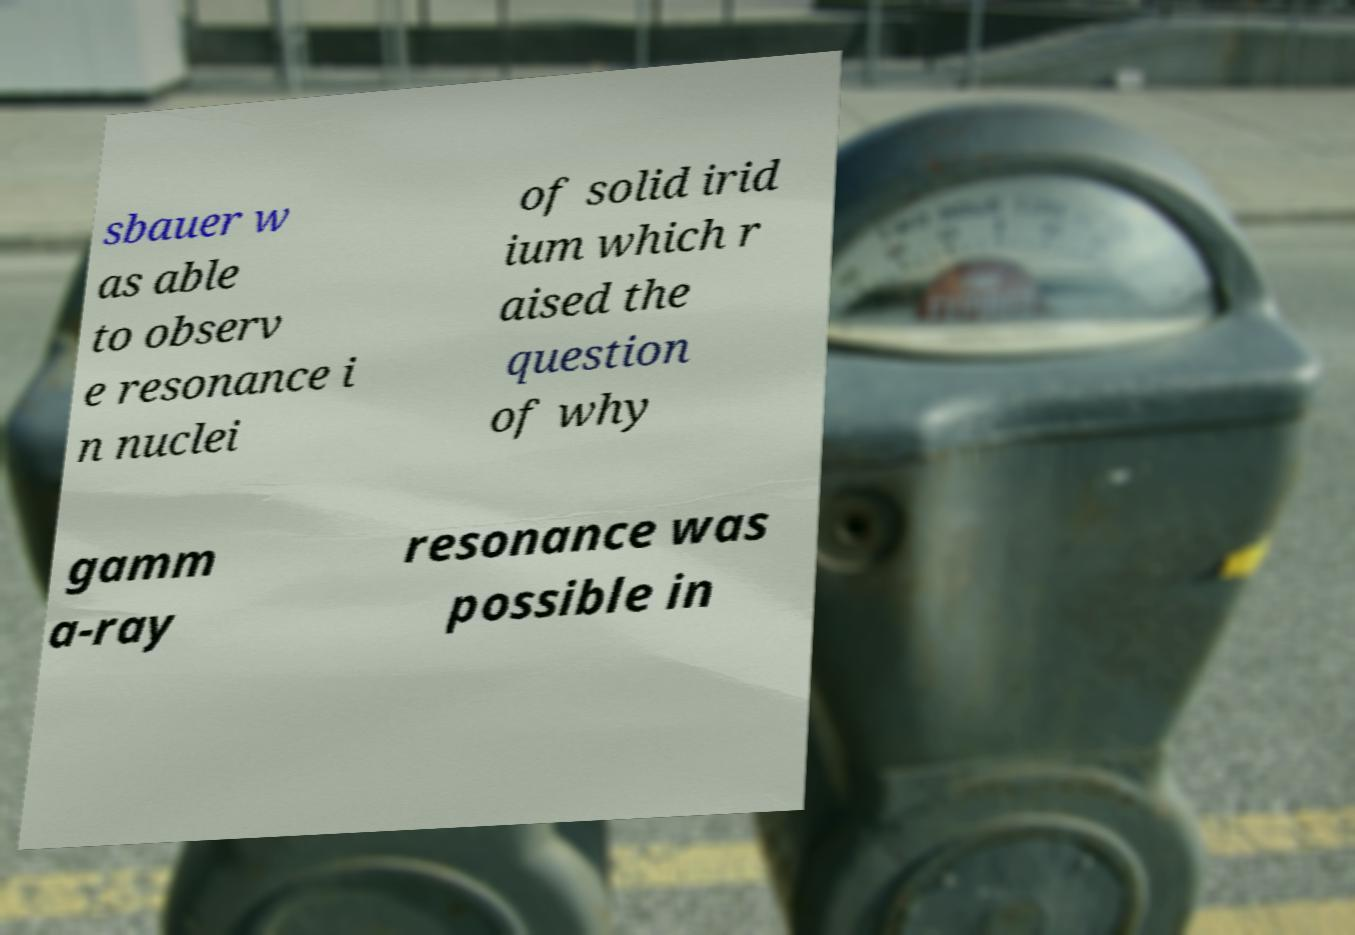For documentation purposes, I need the text within this image transcribed. Could you provide that? sbauer w as able to observ e resonance i n nuclei of solid irid ium which r aised the question of why gamm a-ray resonance was possible in 